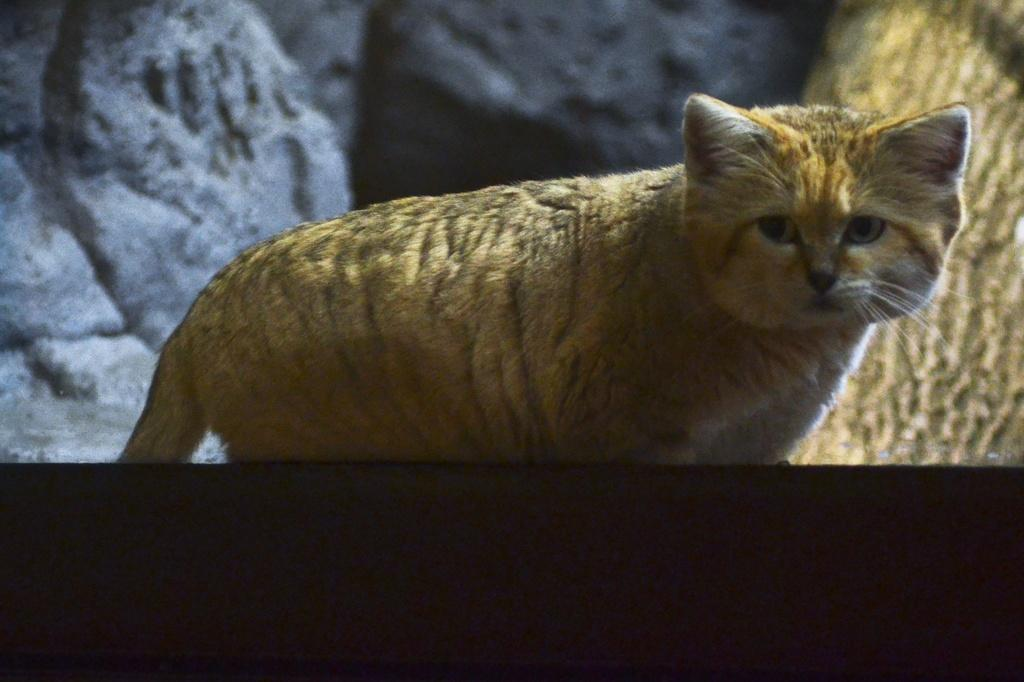What type of animal is in the image? There is a cat in the image. What colors can be seen on the cat? The cat has gold, white, and black colors. What can be seen in the background of the image? There are blurry objects in the background of the image. What type of chicken is being served for dinner in the image? There is no chicken or dinner scene present in the image; it features a cat with specific colors. 